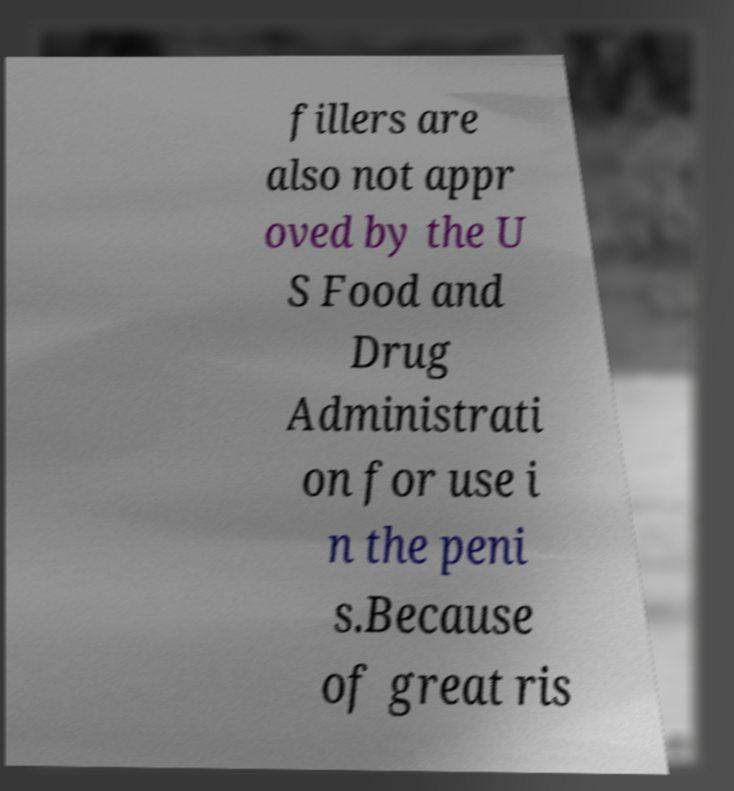Please read and relay the text visible in this image. What does it say? fillers are also not appr oved by the U S Food and Drug Administrati on for use i n the peni s.Because of great ris 